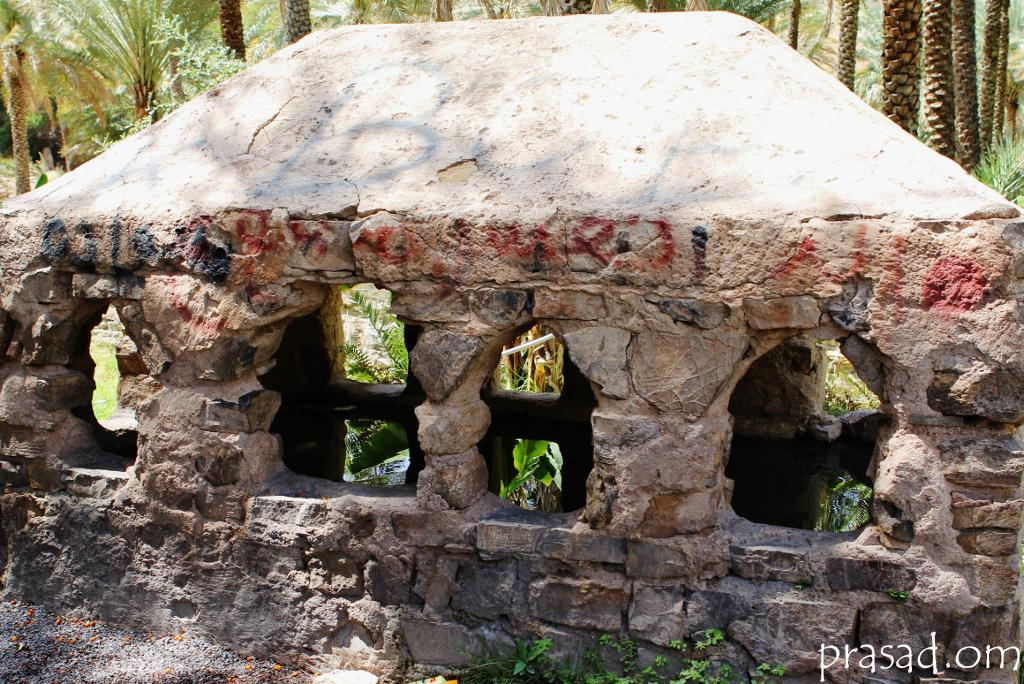What type of room is depicted in the image? There is a stone room in the image. What can be seen behind the stone room? There are trees visible behind the stone room. Are there any flowers visible in the stone room? There is no mention of flowers in the image, so we cannot determine if any are present. 